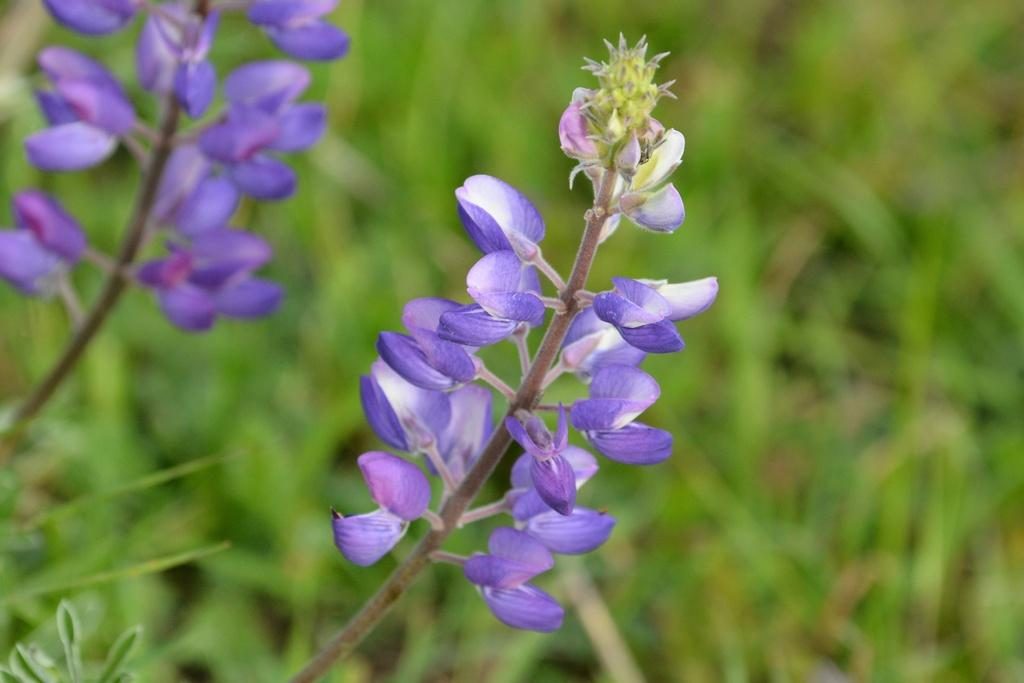What type of plants are in the image? There are flowers in the image. What colors are the flowers? The flowers are white and purple in color. What can be seen in the background of the image? The background of the image is green. Where is the jar of rice placed in the image? There is no jar of rice present in the image. What type of crown can be seen on the flowers in the image? There is no crown present on the flowers in the image. 